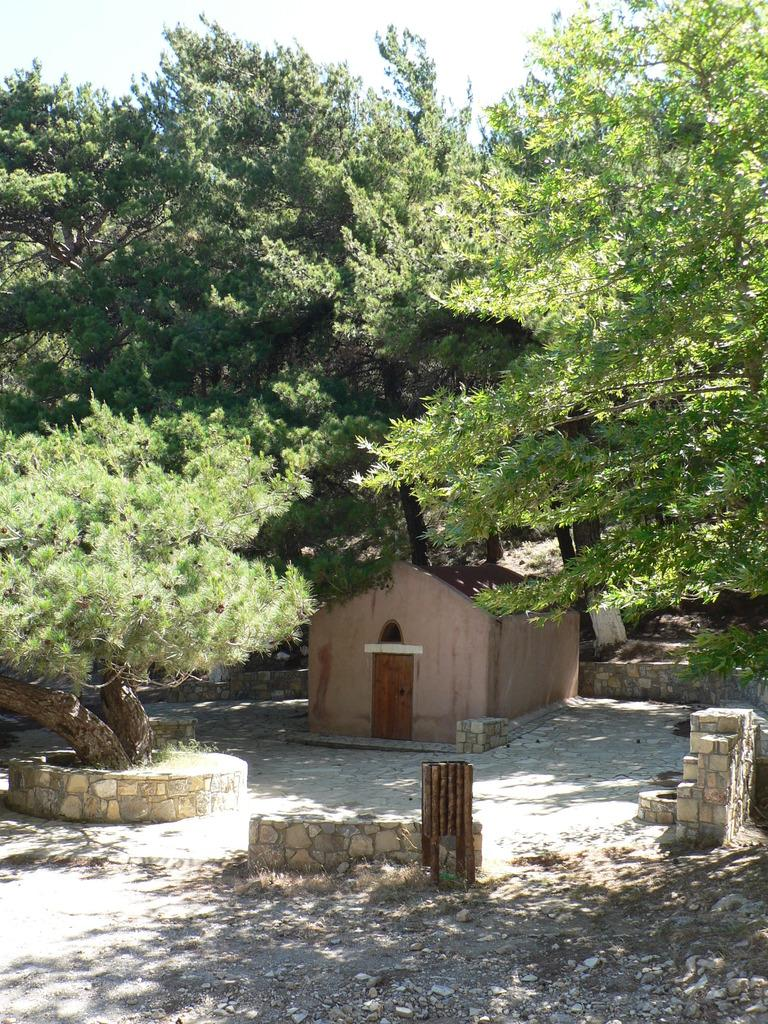What type of structure is present in the image? There is a shed in the image. What other natural elements can be seen in the image? There are trees in the image. What is visible at the top of the image? The sky is visible at the top of the image. What type of instrument is being played by the dinosaurs in the image? There are no dinosaurs or instruments present in the image. 